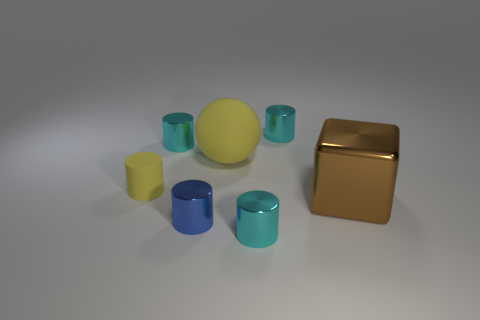Are there an equal number of tiny cyan objects that are on the right side of the blue thing and brown rubber balls?
Ensure brevity in your answer.  No. There is a yellow object that is the same size as the blue shiny cylinder; what shape is it?
Offer a very short reply. Cylinder. How many other things are there of the same shape as the big brown metallic object?
Offer a very short reply. 0. Is the size of the brown object the same as the cyan cylinder that is in front of the big metallic cube?
Your response must be concise. No. How many things are small cylinders in front of the yellow cylinder or large things?
Offer a very short reply. 4. What shape is the yellow thing behind the tiny yellow matte object?
Offer a terse response. Sphere. Are there an equal number of things right of the big brown block and blue metal cylinders that are left of the tiny rubber cylinder?
Provide a short and direct response. Yes. What is the color of the small cylinder that is both behind the tiny blue shiny cylinder and in front of the big yellow matte ball?
Ensure brevity in your answer.  Yellow. There is a cyan object that is to the left of the small cyan shiny thing that is in front of the yellow matte ball; what is its material?
Provide a short and direct response. Metal. Is the size of the yellow rubber ball the same as the yellow rubber cylinder?
Your response must be concise. No. 